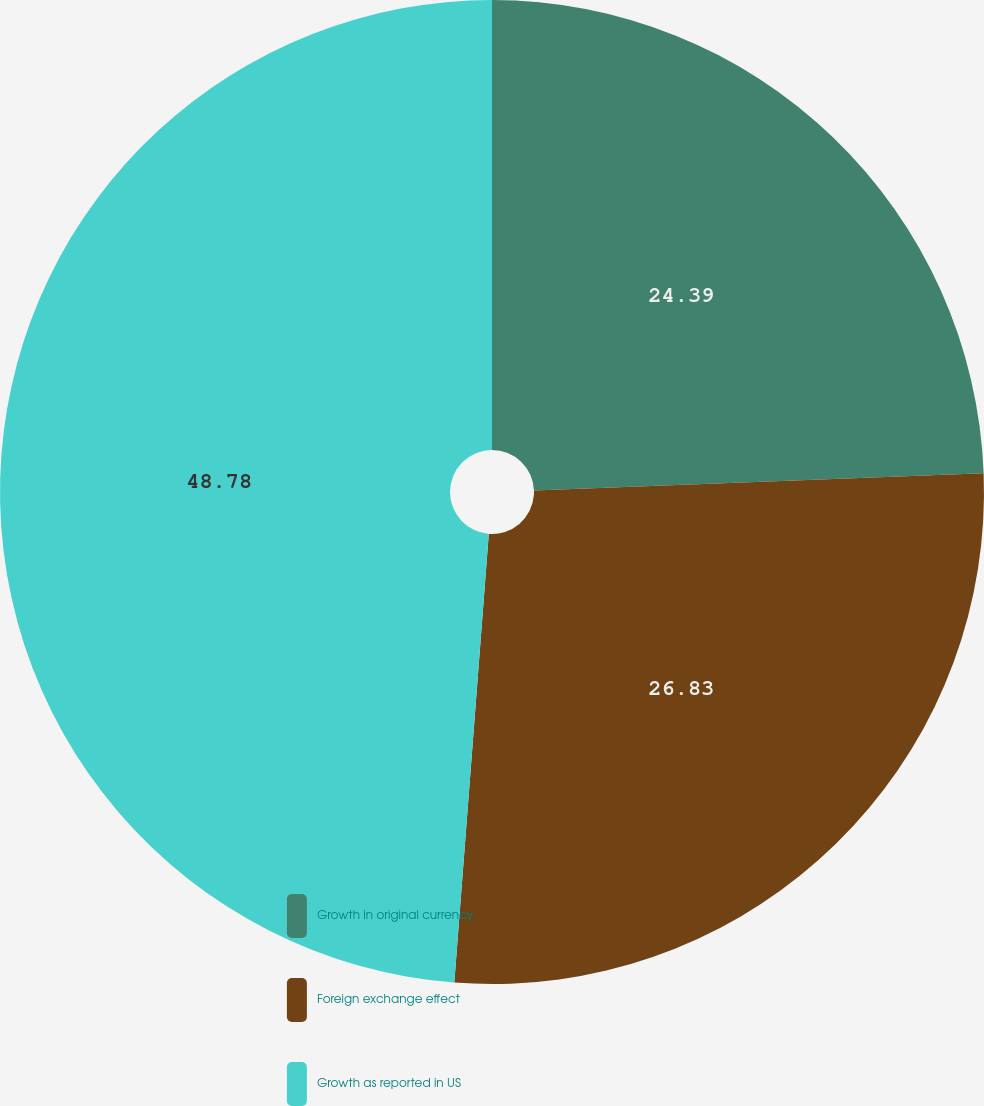<chart> <loc_0><loc_0><loc_500><loc_500><pie_chart><fcel>Growth in original currency<fcel>Foreign exchange effect<fcel>Growth as reported in US<nl><fcel>24.39%<fcel>26.83%<fcel>48.78%<nl></chart> 